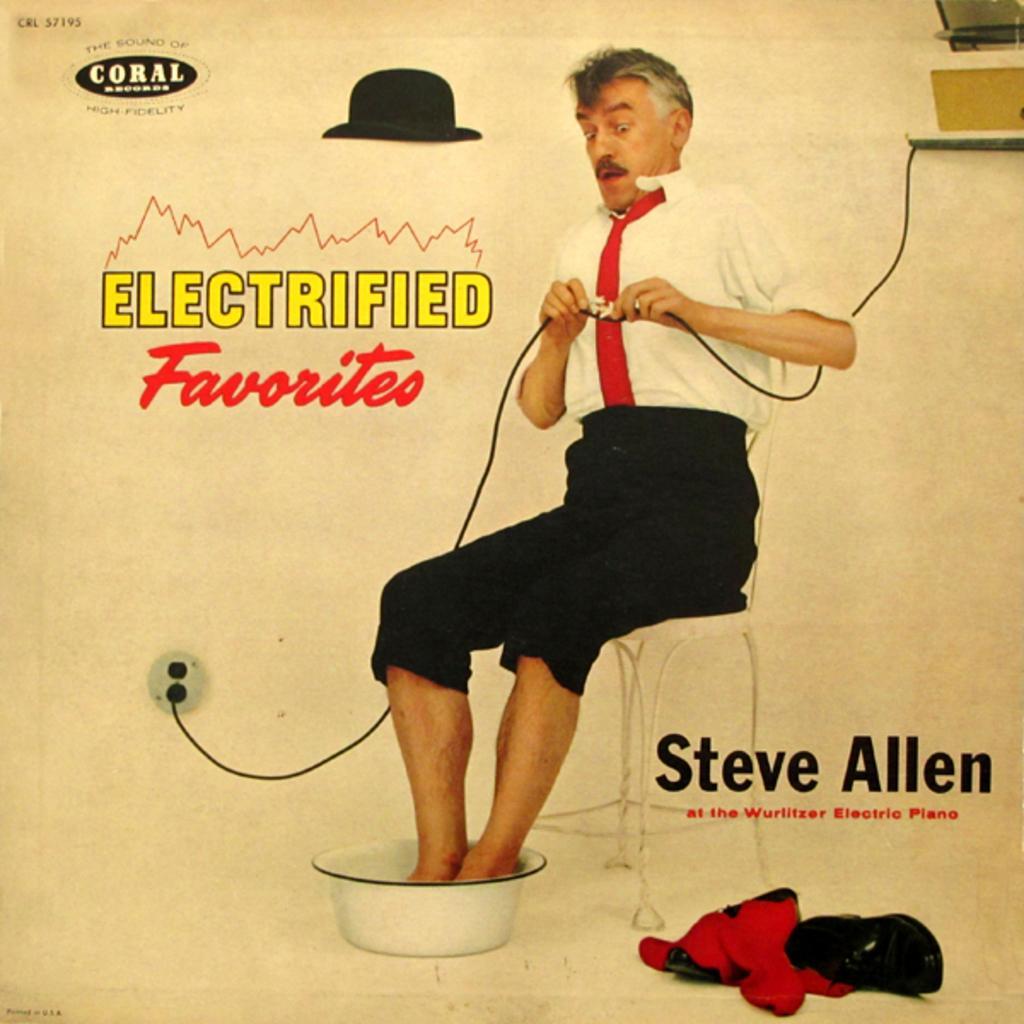Please provide a concise description of this image. This is an advertisement and here we can see an image of a person holding a wire and sitting on the chair and putting his legs in the tub. In the background, we can see some objects and there is some text. 